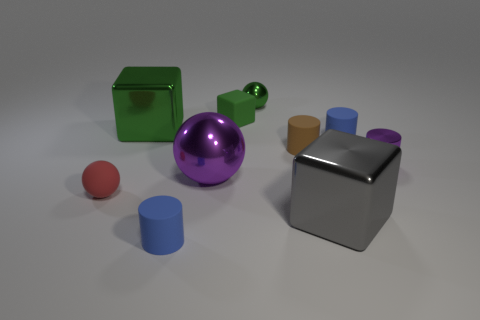What can be inferred about the lighting condition in the scene? Analyzing the image, it appears to have a single bright light source, given the distinct shadows cast by each object. The light source seems to be positioned above and to the right of the objects, as evidenced by the direction and length of the shadows. Does the shadow direction help identify the time of day? In a real-world outdoor setting, shadow direction can indeed indicate the time of day. However, this image looks like a digitally rendered scene or a controlled indoor setup where the light source is artificial, making it impossible to determine the time of day based on shadows alone. 